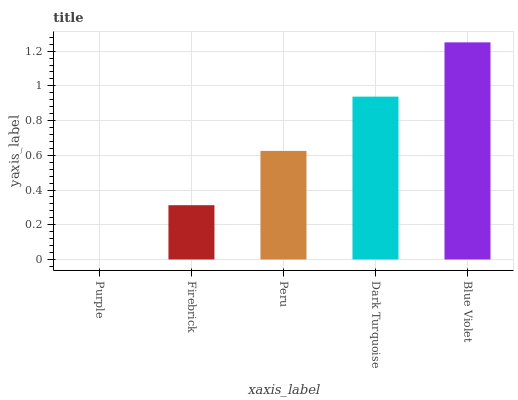Is Purple the minimum?
Answer yes or no. Yes. Is Blue Violet the maximum?
Answer yes or no. Yes. Is Firebrick the minimum?
Answer yes or no. No. Is Firebrick the maximum?
Answer yes or no. No. Is Firebrick greater than Purple?
Answer yes or no. Yes. Is Purple less than Firebrick?
Answer yes or no. Yes. Is Purple greater than Firebrick?
Answer yes or no. No. Is Firebrick less than Purple?
Answer yes or no. No. Is Peru the high median?
Answer yes or no. Yes. Is Peru the low median?
Answer yes or no. Yes. Is Purple the high median?
Answer yes or no. No. Is Blue Violet the low median?
Answer yes or no. No. 